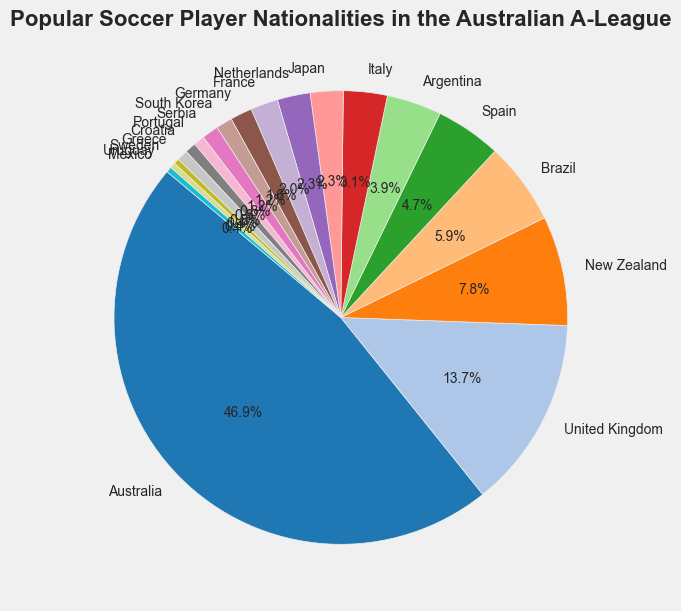What percentage of players come from Australia? Australia has a count of 120 players out of the total (120 + 35 + 20 + 15 + 12 + 10 + 8 + 6 + 6 + 5 + 4 + 3 + 3 + 2 + 2 + 2 + 1 + 1 + 1) = 256 players. The percentage is (120/256) * 100.
Answer: 46.9% Which country contributes the second highest number of players? The count for the United Kingdom is 35, which is the second largest count after Australia.
Answer: United Kingdom How many more players are from Australia than from the United Kingdom? Subtract the number of players from the United Kingdom (35) from the number of players from Australia (120). 120 - 35 = 85.
Answer: 85 What is the combined percentage of players from Brazil and Spain? Brazil has 15 players and Spain has 12, making a total of 27 players. The percentage is (27/256) * 100.
Answer: 10.5% Is the percentage of New Zealand players higher than that of Japan? New Zealand has 20 players and Japan has 6. The percentage for New Zealand is (20/256) * 100 = 7.8%, and for Japan, it is (6/256) * 100 = 2.3%.
Answer: Yes Which country has the fewest players, and how many are there? Sweden, Uruguay, and Mexico each have 1 player, which is the fewest.
Answer: Sweden, Uruguay, Mexico; 1 How many players are from European countries in total? European countries listed are the United Kingdom (35), Spain (12), Italy (8), Netherlands (6), France (5), Germany (4), Serbia (3), Portugal (2), Croatia (2), and Greece (2). Adding them gives 35 + 12 + 8 + 6 + 5 + 4 + 3 + 2 + 2 + 2 = 79.
Answer: 79 Are there more players from South America or Asia? South American countries listed are Brazil (15), Argentina (10), and Uruguay (1), giving a total of 26. Asian countries listed are South Korea (3) and Japan (6), giving a total of 9.
Answer: South America What is the percentage difference between players from Brazil and Argentina? Brazil has 15 players, and Argentina has 10 players. The difference is (15 - 10) / 256 * 100 = 1.95%.
Answer: 1.95% How does the percentage of players from the top three countries compare to the total? The counts for Australia (120), United Kingdom (35), and New Zealand (20) sum to 175. The percentage is (175/256) * 100.
Answer: 68.4% 